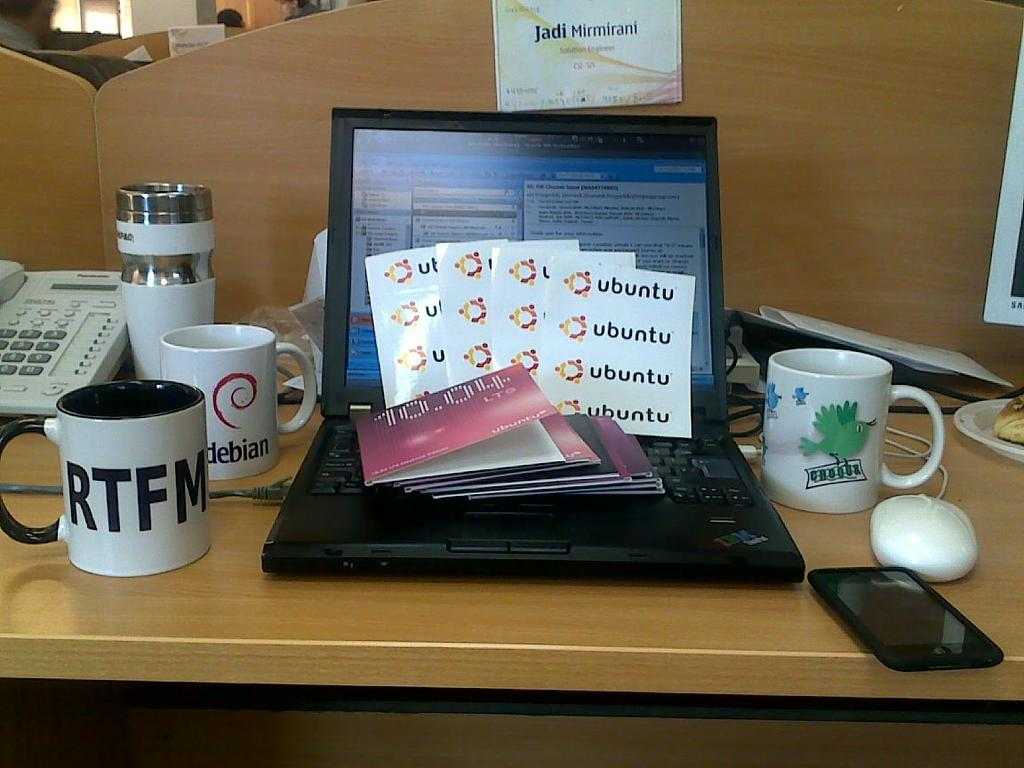What piece of furniture is present in the image? There is a table in the image. What electronic device is on the table? There is a laptop on the table. What type of containers are on the table? There are cups on the table. What communication device is on the table? There is a telephone on the table. What type of portable electronic device is on the table? There is a mobile on the table. Can you see any mountains in the image? There are no mountains present in the image. How many cents are visible on the table in the image? There are no cents present in the image. 